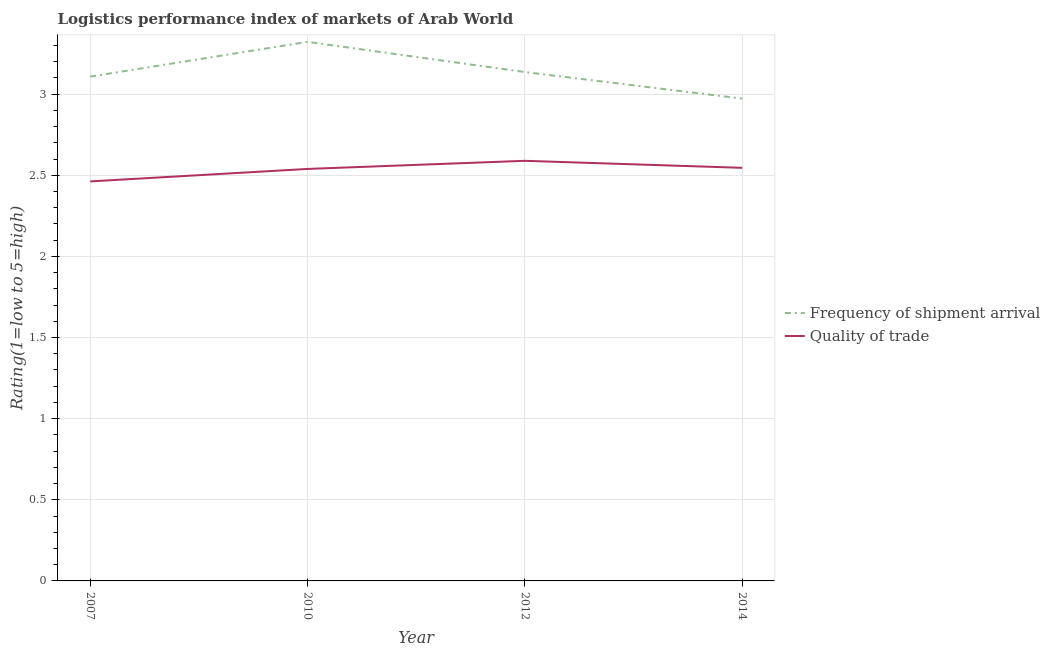How many different coloured lines are there?
Keep it short and to the point. 2. Is the number of lines equal to the number of legend labels?
Your answer should be compact. Yes. What is the lpi quality of trade in 2014?
Keep it short and to the point. 2.55. Across all years, what is the maximum lpi of frequency of shipment arrival?
Your answer should be very brief. 3.32. Across all years, what is the minimum lpi of frequency of shipment arrival?
Offer a very short reply. 2.97. What is the total lpi of frequency of shipment arrival in the graph?
Offer a very short reply. 12.54. What is the difference between the lpi of frequency of shipment arrival in 2007 and that in 2014?
Ensure brevity in your answer.  0.14. What is the difference between the lpi quality of trade in 2010 and the lpi of frequency of shipment arrival in 2014?
Offer a terse response. -0.43. What is the average lpi of frequency of shipment arrival per year?
Ensure brevity in your answer.  3.13. In the year 2012, what is the difference between the lpi of frequency of shipment arrival and lpi quality of trade?
Offer a very short reply. 0.55. What is the ratio of the lpi of frequency of shipment arrival in 2010 to that in 2014?
Your answer should be very brief. 1.12. Is the difference between the lpi quality of trade in 2007 and 2012 greater than the difference between the lpi of frequency of shipment arrival in 2007 and 2012?
Give a very brief answer. No. What is the difference between the highest and the second highest lpi of frequency of shipment arrival?
Your answer should be compact. 0.19. What is the difference between the highest and the lowest lpi quality of trade?
Offer a terse response. 0.13. Is the sum of the lpi of frequency of shipment arrival in 2012 and 2014 greater than the maximum lpi quality of trade across all years?
Provide a short and direct response. Yes. Is the lpi of frequency of shipment arrival strictly greater than the lpi quality of trade over the years?
Make the answer very short. Yes. How many lines are there?
Ensure brevity in your answer.  2. What is the difference between two consecutive major ticks on the Y-axis?
Offer a terse response. 0.5. Does the graph contain grids?
Your answer should be very brief. Yes. Where does the legend appear in the graph?
Your answer should be very brief. Center right. What is the title of the graph?
Provide a succinct answer. Logistics performance index of markets of Arab World. Does "Transport services" appear as one of the legend labels in the graph?
Offer a very short reply. No. What is the label or title of the X-axis?
Give a very brief answer. Year. What is the label or title of the Y-axis?
Make the answer very short. Rating(1=low to 5=high). What is the Rating(1=low to 5=high) in Frequency of shipment arrival in 2007?
Give a very brief answer. 3.11. What is the Rating(1=low to 5=high) in Quality of trade in 2007?
Your answer should be very brief. 2.46. What is the Rating(1=low to 5=high) in Frequency of shipment arrival in 2010?
Make the answer very short. 3.32. What is the Rating(1=low to 5=high) in Quality of trade in 2010?
Your response must be concise. 2.54. What is the Rating(1=low to 5=high) of Frequency of shipment arrival in 2012?
Your answer should be compact. 3.14. What is the Rating(1=low to 5=high) of Quality of trade in 2012?
Ensure brevity in your answer.  2.59. What is the Rating(1=low to 5=high) of Frequency of shipment arrival in 2014?
Provide a succinct answer. 2.97. What is the Rating(1=low to 5=high) in Quality of trade in 2014?
Provide a succinct answer. 2.55. Across all years, what is the maximum Rating(1=low to 5=high) of Frequency of shipment arrival?
Provide a succinct answer. 3.32. Across all years, what is the maximum Rating(1=low to 5=high) of Quality of trade?
Your answer should be compact. 2.59. Across all years, what is the minimum Rating(1=low to 5=high) of Frequency of shipment arrival?
Give a very brief answer. 2.97. Across all years, what is the minimum Rating(1=low to 5=high) in Quality of trade?
Keep it short and to the point. 2.46. What is the total Rating(1=low to 5=high) of Frequency of shipment arrival in the graph?
Provide a short and direct response. 12.54. What is the total Rating(1=low to 5=high) of Quality of trade in the graph?
Your response must be concise. 10.14. What is the difference between the Rating(1=low to 5=high) of Frequency of shipment arrival in 2007 and that in 2010?
Give a very brief answer. -0.21. What is the difference between the Rating(1=low to 5=high) in Quality of trade in 2007 and that in 2010?
Offer a terse response. -0.08. What is the difference between the Rating(1=low to 5=high) of Frequency of shipment arrival in 2007 and that in 2012?
Your response must be concise. -0.03. What is the difference between the Rating(1=low to 5=high) in Quality of trade in 2007 and that in 2012?
Ensure brevity in your answer.  -0.13. What is the difference between the Rating(1=low to 5=high) in Frequency of shipment arrival in 2007 and that in 2014?
Ensure brevity in your answer.  0.14. What is the difference between the Rating(1=low to 5=high) of Quality of trade in 2007 and that in 2014?
Offer a terse response. -0.08. What is the difference between the Rating(1=low to 5=high) of Frequency of shipment arrival in 2010 and that in 2012?
Ensure brevity in your answer.  0.19. What is the difference between the Rating(1=low to 5=high) of Quality of trade in 2010 and that in 2012?
Your response must be concise. -0.05. What is the difference between the Rating(1=low to 5=high) of Frequency of shipment arrival in 2010 and that in 2014?
Your answer should be compact. 0.35. What is the difference between the Rating(1=low to 5=high) of Quality of trade in 2010 and that in 2014?
Your answer should be very brief. -0.01. What is the difference between the Rating(1=low to 5=high) in Frequency of shipment arrival in 2012 and that in 2014?
Keep it short and to the point. 0.16. What is the difference between the Rating(1=low to 5=high) of Quality of trade in 2012 and that in 2014?
Your response must be concise. 0.04. What is the difference between the Rating(1=low to 5=high) in Frequency of shipment arrival in 2007 and the Rating(1=low to 5=high) in Quality of trade in 2010?
Keep it short and to the point. 0.57. What is the difference between the Rating(1=low to 5=high) of Frequency of shipment arrival in 2007 and the Rating(1=low to 5=high) of Quality of trade in 2012?
Your answer should be very brief. 0.52. What is the difference between the Rating(1=low to 5=high) in Frequency of shipment arrival in 2007 and the Rating(1=low to 5=high) in Quality of trade in 2014?
Give a very brief answer. 0.56. What is the difference between the Rating(1=low to 5=high) of Frequency of shipment arrival in 2010 and the Rating(1=low to 5=high) of Quality of trade in 2012?
Offer a terse response. 0.73. What is the difference between the Rating(1=low to 5=high) in Frequency of shipment arrival in 2010 and the Rating(1=low to 5=high) in Quality of trade in 2014?
Your response must be concise. 0.78. What is the difference between the Rating(1=low to 5=high) of Frequency of shipment arrival in 2012 and the Rating(1=low to 5=high) of Quality of trade in 2014?
Your answer should be very brief. 0.59. What is the average Rating(1=low to 5=high) in Frequency of shipment arrival per year?
Your response must be concise. 3.13. What is the average Rating(1=low to 5=high) in Quality of trade per year?
Your answer should be very brief. 2.53. In the year 2007, what is the difference between the Rating(1=low to 5=high) in Frequency of shipment arrival and Rating(1=low to 5=high) in Quality of trade?
Provide a short and direct response. 0.65. In the year 2010, what is the difference between the Rating(1=low to 5=high) of Frequency of shipment arrival and Rating(1=low to 5=high) of Quality of trade?
Provide a succinct answer. 0.78. In the year 2012, what is the difference between the Rating(1=low to 5=high) of Frequency of shipment arrival and Rating(1=low to 5=high) of Quality of trade?
Your answer should be very brief. 0.55. In the year 2014, what is the difference between the Rating(1=low to 5=high) in Frequency of shipment arrival and Rating(1=low to 5=high) in Quality of trade?
Offer a very short reply. 0.43. What is the ratio of the Rating(1=low to 5=high) of Frequency of shipment arrival in 2007 to that in 2010?
Give a very brief answer. 0.94. What is the ratio of the Rating(1=low to 5=high) in Quality of trade in 2007 to that in 2010?
Your answer should be compact. 0.97. What is the ratio of the Rating(1=low to 5=high) in Frequency of shipment arrival in 2007 to that in 2012?
Give a very brief answer. 0.99. What is the ratio of the Rating(1=low to 5=high) in Quality of trade in 2007 to that in 2012?
Your answer should be very brief. 0.95. What is the ratio of the Rating(1=low to 5=high) of Frequency of shipment arrival in 2007 to that in 2014?
Provide a succinct answer. 1.05. What is the ratio of the Rating(1=low to 5=high) of Quality of trade in 2007 to that in 2014?
Your answer should be compact. 0.97. What is the ratio of the Rating(1=low to 5=high) in Frequency of shipment arrival in 2010 to that in 2012?
Your answer should be very brief. 1.06. What is the ratio of the Rating(1=low to 5=high) in Quality of trade in 2010 to that in 2012?
Keep it short and to the point. 0.98. What is the ratio of the Rating(1=low to 5=high) of Frequency of shipment arrival in 2010 to that in 2014?
Ensure brevity in your answer.  1.12. What is the ratio of the Rating(1=low to 5=high) of Quality of trade in 2010 to that in 2014?
Your response must be concise. 1. What is the ratio of the Rating(1=low to 5=high) in Frequency of shipment arrival in 2012 to that in 2014?
Your answer should be compact. 1.06. What is the difference between the highest and the second highest Rating(1=low to 5=high) in Frequency of shipment arrival?
Provide a short and direct response. 0.19. What is the difference between the highest and the second highest Rating(1=low to 5=high) in Quality of trade?
Make the answer very short. 0.04. What is the difference between the highest and the lowest Rating(1=low to 5=high) of Frequency of shipment arrival?
Keep it short and to the point. 0.35. What is the difference between the highest and the lowest Rating(1=low to 5=high) in Quality of trade?
Offer a terse response. 0.13. 